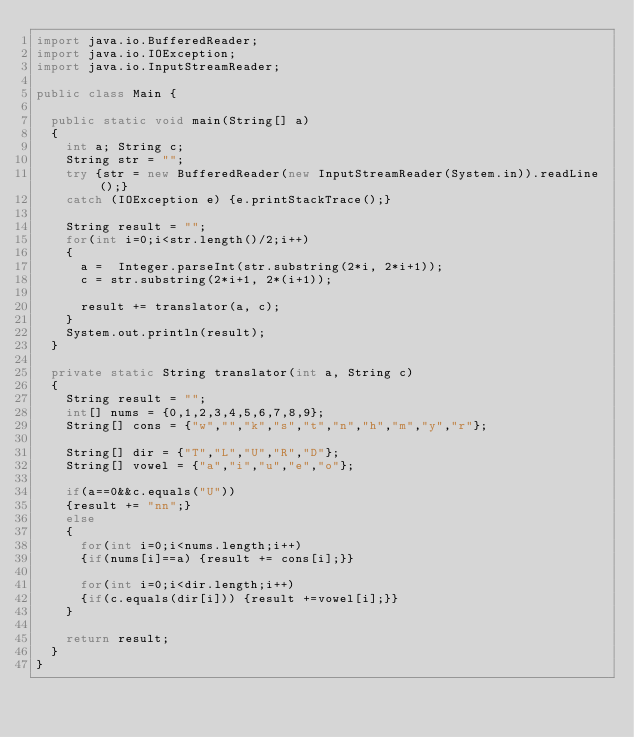<code> <loc_0><loc_0><loc_500><loc_500><_Java_>import java.io.BufferedReader;
import java.io.IOException;
import java.io.InputStreamReader;

public class Main {

	public static void main(String[] a)
	{
		int a; String c;
		String str = "";
		try {str = new BufferedReader(new InputStreamReader(System.in)).readLine();}
		catch (IOException e) {e.printStackTrace();}

		String result = "";
		for(int i=0;i<str.length()/2;i++)
		{
			a =  Integer.parseInt(str.substring(2*i, 2*i+1));
			c = str.substring(2*i+1, 2*(i+1));

			result += translator(a, c);
		}
		System.out.println(result);
	}

	private static String translator(int a, String c)
	{
		String result = "";
		int[] nums = {0,1,2,3,4,5,6,7,8,9};
		String[] cons = {"w","","k","s","t","n","h","m","y","r"};

		String[] dir = {"T","L","U","R","D"};
		String[] vowel = {"a","i","u","e","o"};

		if(a==0&&c.equals("U"))
		{result += "nn";}
		else
		{
			for(int i=0;i<nums.length;i++)
			{if(nums[i]==a) {result += cons[i];}}

			for(int i=0;i<dir.length;i++)
			{if(c.equals(dir[i])) {result +=vowel[i];}}
		}

		return result;
	}
}</code> 